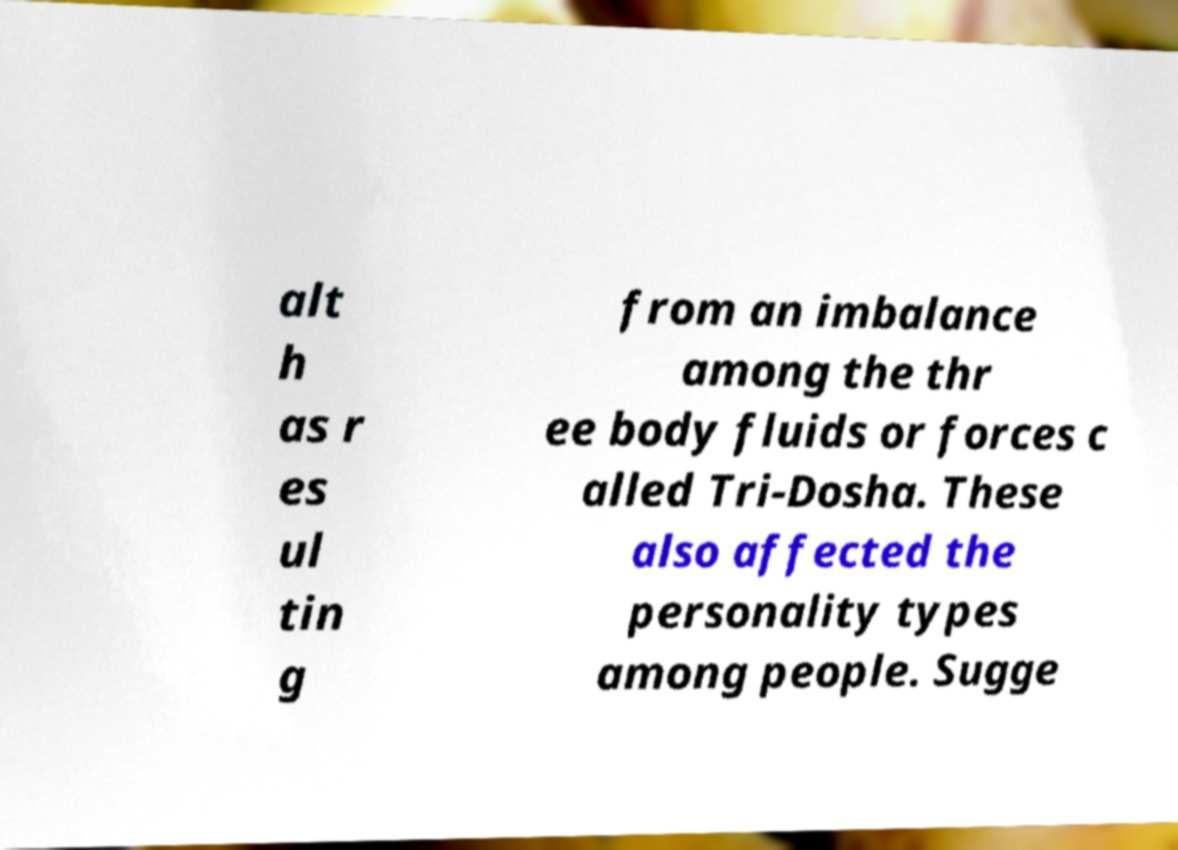Can you read and provide the text displayed in the image?This photo seems to have some interesting text. Can you extract and type it out for me? alt h as r es ul tin g from an imbalance among the thr ee body fluids or forces c alled Tri-Dosha. These also affected the personality types among people. Sugge 